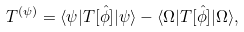Convert formula to latex. <formula><loc_0><loc_0><loc_500><loc_500>T ^ { ( \psi ) } = \langle \psi | T [ \hat { \phi } ] | \psi \rangle - \langle \Omega | T [ \hat { \phi } ] | \Omega \rangle ,</formula> 